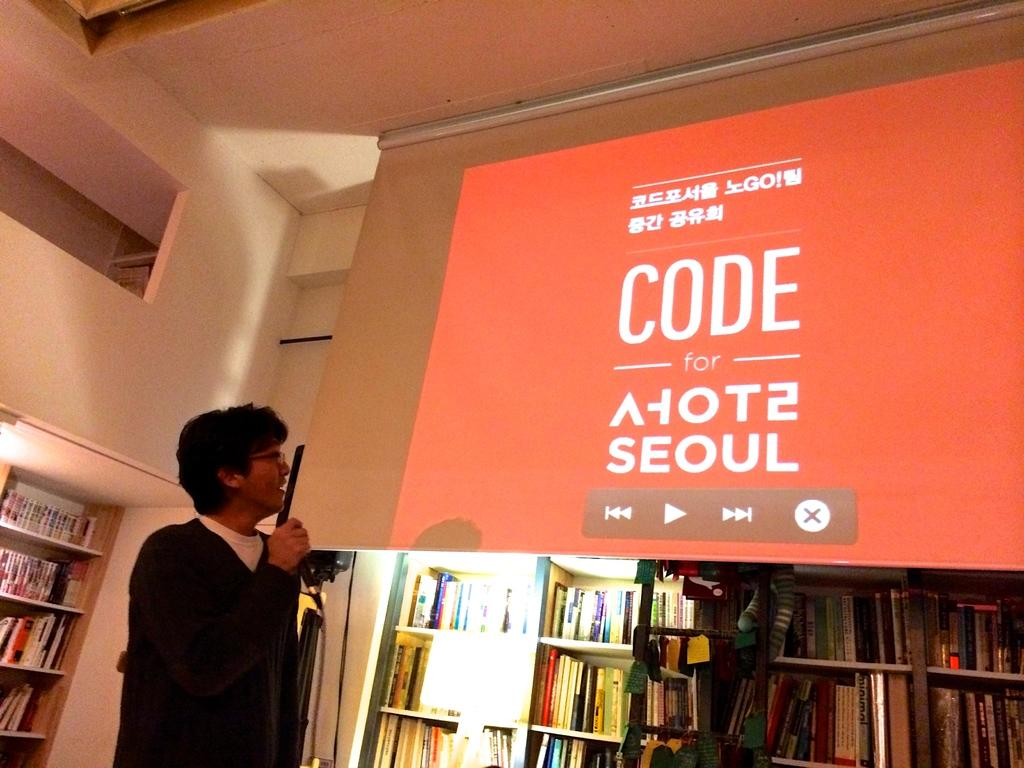<image>
Summarize the visual content of the image. A man talking into a microphone is looking up at a projection of something that has to do with Seoul. 